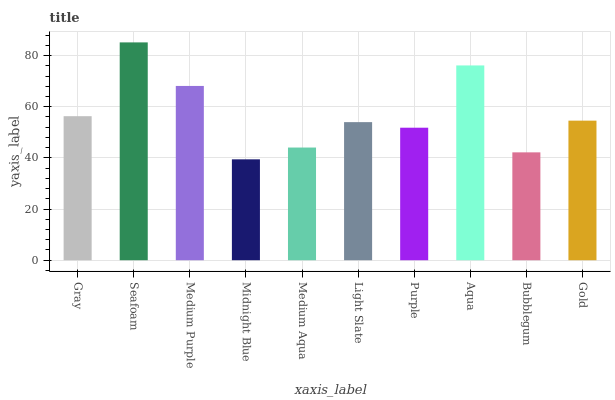Is Midnight Blue the minimum?
Answer yes or no. Yes. Is Seafoam the maximum?
Answer yes or no. Yes. Is Medium Purple the minimum?
Answer yes or no. No. Is Medium Purple the maximum?
Answer yes or no. No. Is Seafoam greater than Medium Purple?
Answer yes or no. Yes. Is Medium Purple less than Seafoam?
Answer yes or no. Yes. Is Medium Purple greater than Seafoam?
Answer yes or no. No. Is Seafoam less than Medium Purple?
Answer yes or no. No. Is Gold the high median?
Answer yes or no. Yes. Is Light Slate the low median?
Answer yes or no. Yes. Is Purple the high median?
Answer yes or no. No. Is Gray the low median?
Answer yes or no. No. 